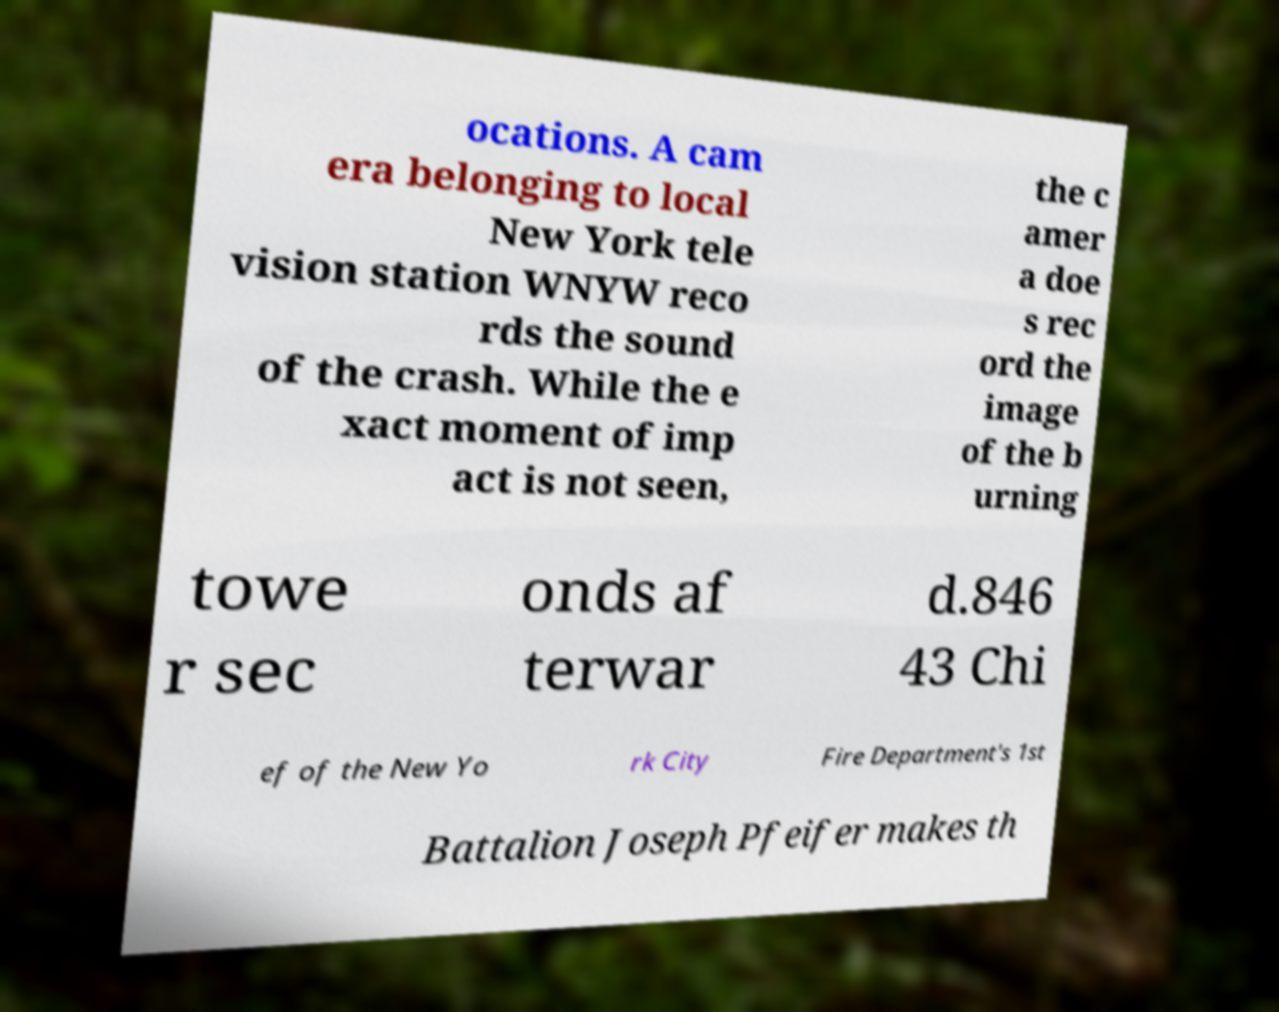Could you extract and type out the text from this image? ocations. A cam era belonging to local New York tele vision station WNYW reco rds the sound of the crash. While the e xact moment of imp act is not seen, the c amer a doe s rec ord the image of the b urning towe r sec onds af terwar d.846 43 Chi ef of the New Yo rk City Fire Department's 1st Battalion Joseph Pfeifer makes th 